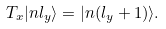<formula> <loc_0><loc_0><loc_500><loc_500>T _ { x } | n l _ { y } \rangle = | n ( l _ { y } + 1 ) \rangle .</formula> 